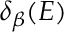<formula> <loc_0><loc_0><loc_500><loc_500>\delta _ { \beta } ( E )</formula> 